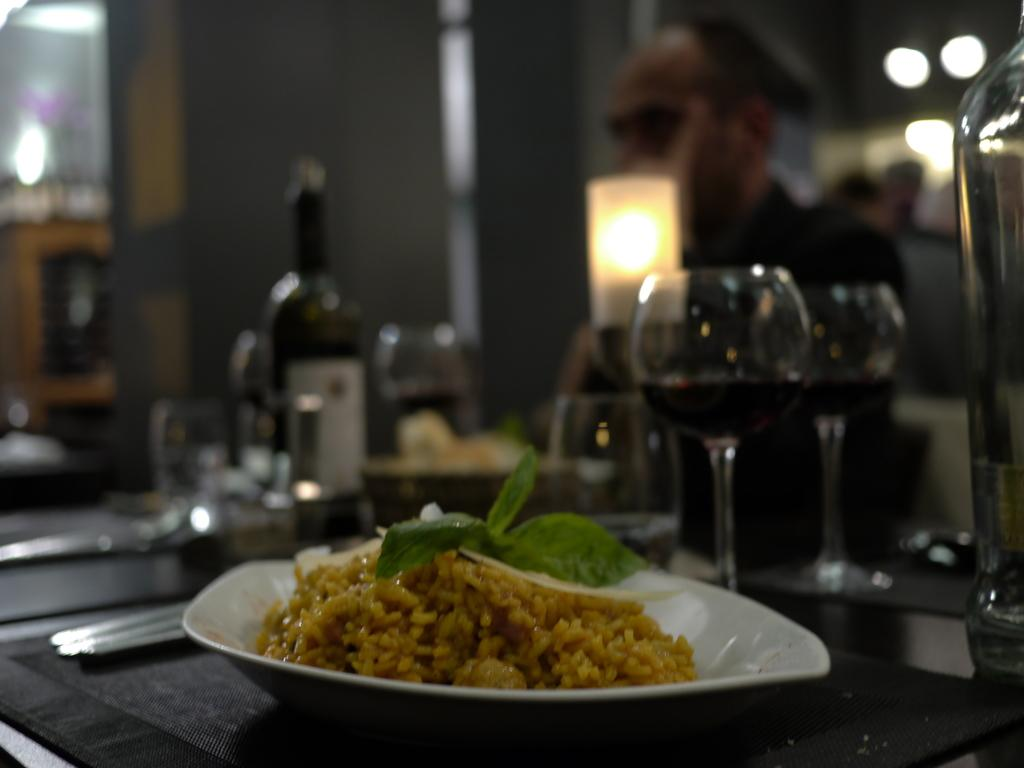What is on the white plate in the image? There is food on a white plate in the image. Where are the wine glasses located in the image? The wine glasses are on the right side of the table in the image. Is there a crook standing next to the food on the plate in the image? No, there is no crook present in the image. Can you see a volcano erupting in the background of the image? No, there is no volcano present in the image. 